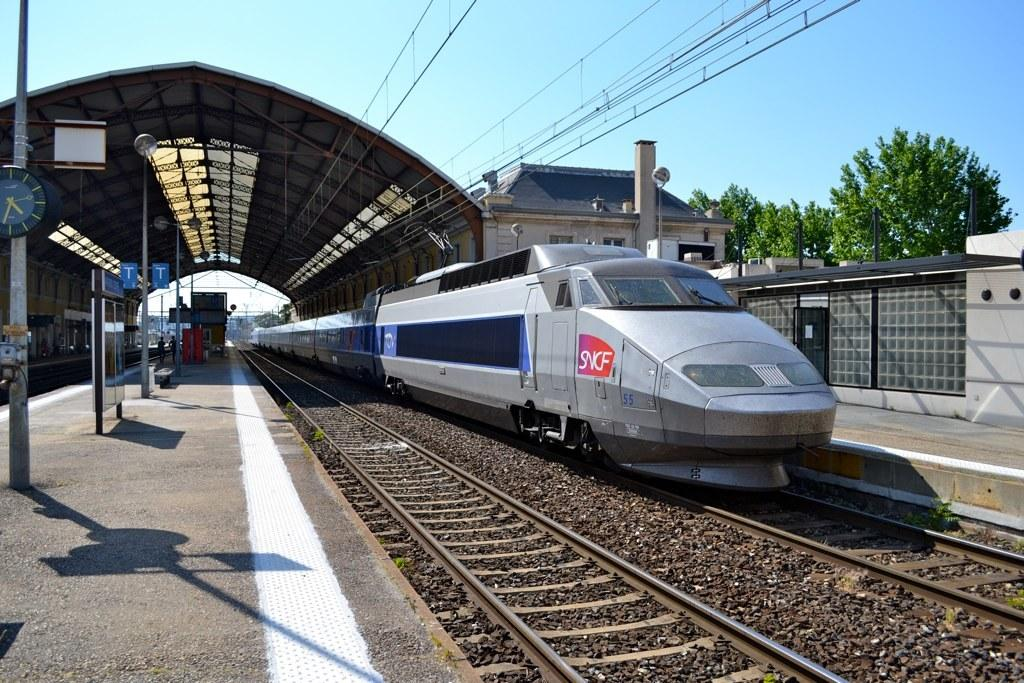<image>
Share a concise interpretation of the image provided. A silver train with a logo in red which reads SNCF on the front. 